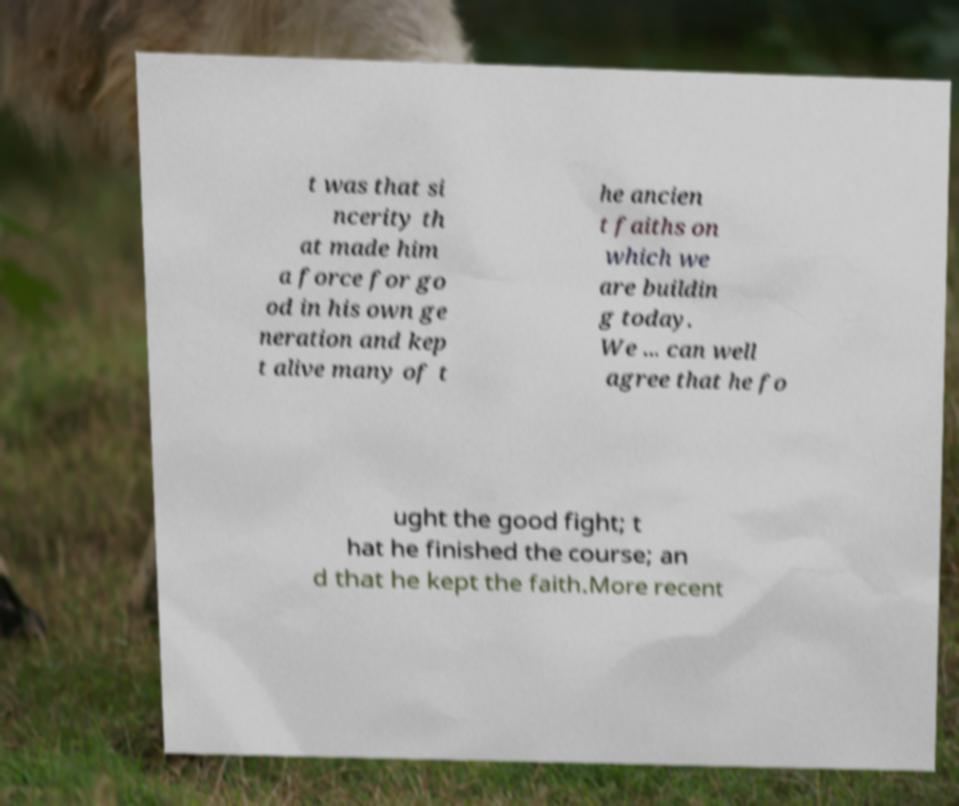For documentation purposes, I need the text within this image transcribed. Could you provide that? t was that si ncerity th at made him a force for go od in his own ge neration and kep t alive many of t he ancien t faiths on which we are buildin g today. We ... can well agree that he fo ught the good fight; t hat he finished the course; an d that he kept the faith.More recent 